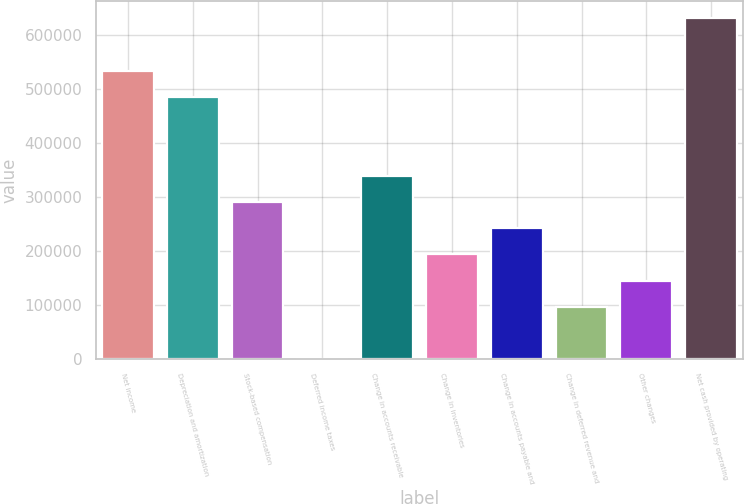Convert chart. <chart><loc_0><loc_0><loc_500><loc_500><bar_chart><fcel>Net income<fcel>Depreciation and amortization<fcel>Stock-based compensation<fcel>Deferred income taxes<fcel>Change in accounts receivable<fcel>Change in inventories<fcel>Change in accounts payable and<fcel>Change in deferred revenue and<fcel>Other changes<fcel>Net cash provided by operating<nl><fcel>533347<fcel>484876<fcel>290993<fcel>169<fcel>339464<fcel>194052<fcel>242522<fcel>97110.4<fcel>145581<fcel>630288<nl></chart> 